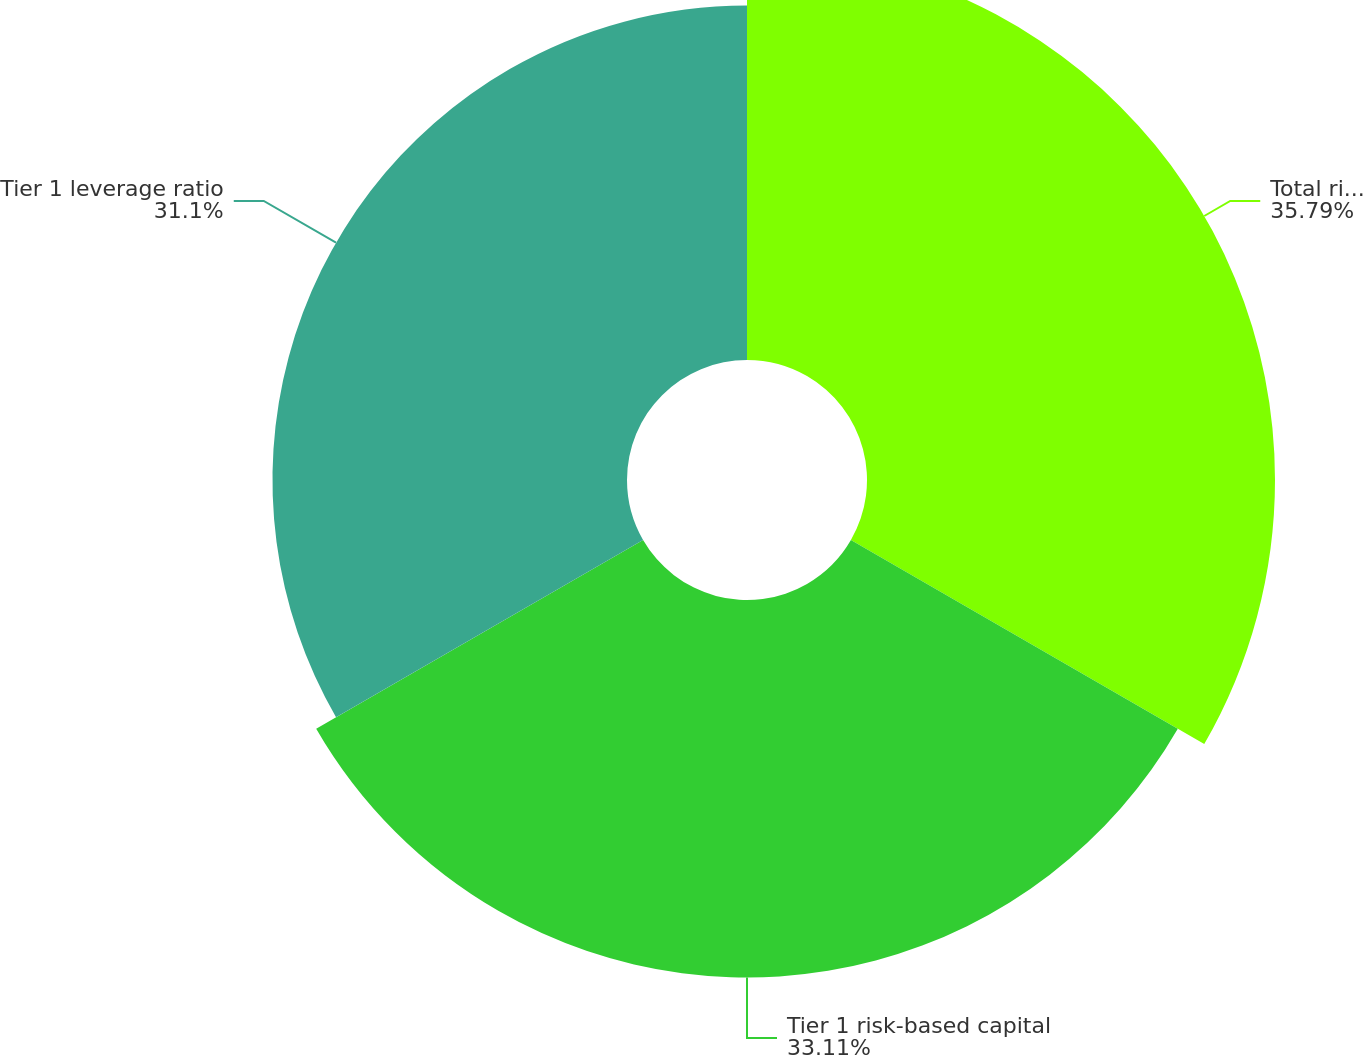Convert chart to OTSL. <chart><loc_0><loc_0><loc_500><loc_500><pie_chart><fcel>Total risk-based capital ratio<fcel>Tier 1 risk-based capital<fcel>Tier 1 leverage ratio<nl><fcel>35.79%<fcel>33.11%<fcel>31.1%<nl></chart> 